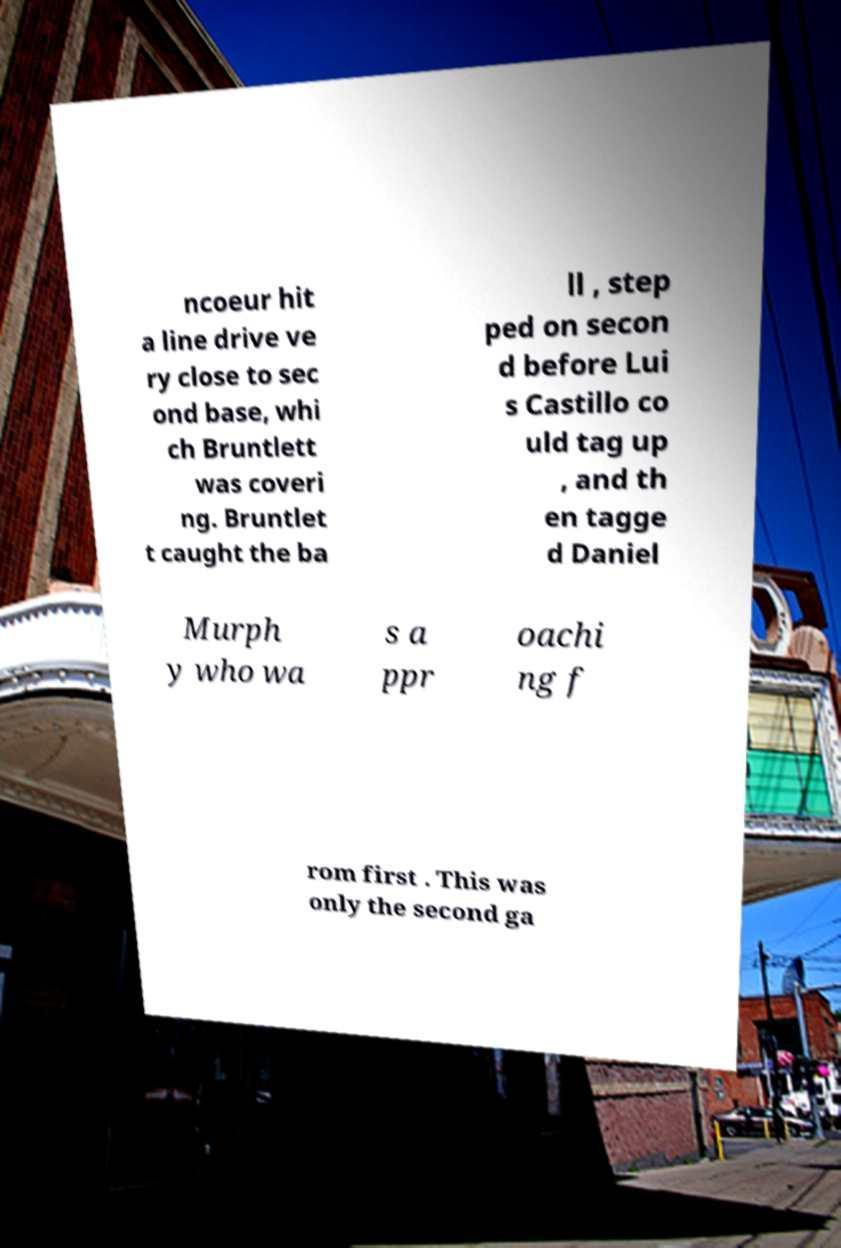Could you extract and type out the text from this image? ncoeur hit a line drive ve ry close to sec ond base, whi ch Bruntlett was coveri ng. Bruntlet t caught the ba ll , step ped on secon d before Lui s Castillo co uld tag up , and th en tagge d Daniel Murph y who wa s a ppr oachi ng f rom first . This was only the second ga 